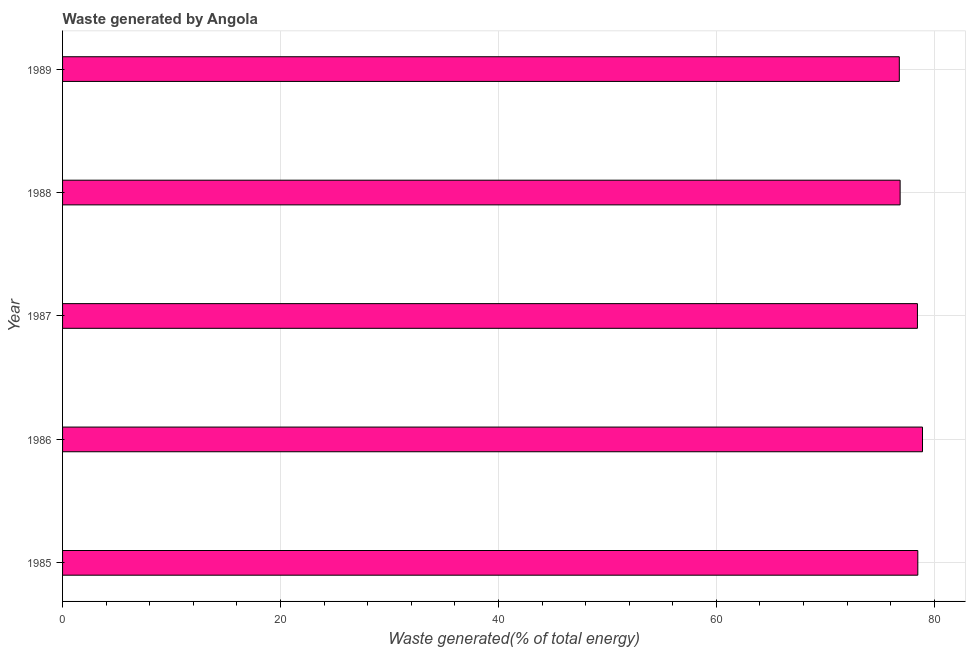Does the graph contain grids?
Offer a very short reply. Yes. What is the title of the graph?
Your response must be concise. Waste generated by Angola. What is the label or title of the X-axis?
Your response must be concise. Waste generated(% of total energy). What is the label or title of the Y-axis?
Your answer should be very brief. Year. What is the amount of waste generated in 1987?
Make the answer very short. 78.45. Across all years, what is the maximum amount of waste generated?
Your answer should be compact. 78.91. Across all years, what is the minimum amount of waste generated?
Give a very brief answer. 76.79. In which year was the amount of waste generated maximum?
Your response must be concise. 1986. In which year was the amount of waste generated minimum?
Keep it short and to the point. 1989. What is the sum of the amount of waste generated?
Provide a short and direct response. 389.5. What is the difference between the amount of waste generated in 1987 and 1988?
Make the answer very short. 1.59. What is the average amount of waste generated per year?
Make the answer very short. 77.9. What is the median amount of waste generated?
Ensure brevity in your answer.  78.45. Do a majority of the years between 1986 and 1985 (inclusive) have amount of waste generated greater than 32 %?
Keep it short and to the point. No. What is the ratio of the amount of waste generated in 1986 to that in 1989?
Give a very brief answer. 1.03. Is the amount of waste generated in 1985 less than that in 1988?
Your answer should be compact. No. Is the difference between the amount of waste generated in 1987 and 1989 greater than the difference between any two years?
Your response must be concise. No. What is the difference between the highest and the second highest amount of waste generated?
Your answer should be very brief. 0.43. Is the sum of the amount of waste generated in 1987 and 1989 greater than the maximum amount of waste generated across all years?
Offer a very short reply. Yes. What is the difference between the highest and the lowest amount of waste generated?
Ensure brevity in your answer.  2.13. What is the Waste generated(% of total energy) of 1985?
Provide a short and direct response. 78.48. What is the Waste generated(% of total energy) of 1986?
Give a very brief answer. 78.91. What is the Waste generated(% of total energy) of 1987?
Provide a succinct answer. 78.45. What is the Waste generated(% of total energy) of 1988?
Your answer should be compact. 76.86. What is the Waste generated(% of total energy) of 1989?
Your answer should be compact. 76.79. What is the difference between the Waste generated(% of total energy) in 1985 and 1986?
Your response must be concise. -0.43. What is the difference between the Waste generated(% of total energy) in 1985 and 1987?
Provide a succinct answer. 0.03. What is the difference between the Waste generated(% of total energy) in 1985 and 1988?
Your answer should be very brief. 1.62. What is the difference between the Waste generated(% of total energy) in 1985 and 1989?
Make the answer very short. 1.7. What is the difference between the Waste generated(% of total energy) in 1986 and 1987?
Provide a short and direct response. 0.46. What is the difference between the Waste generated(% of total energy) in 1986 and 1988?
Provide a short and direct response. 2.05. What is the difference between the Waste generated(% of total energy) in 1986 and 1989?
Give a very brief answer. 2.13. What is the difference between the Waste generated(% of total energy) in 1987 and 1988?
Provide a succinct answer. 1.59. What is the difference between the Waste generated(% of total energy) in 1987 and 1989?
Your response must be concise. 1.66. What is the difference between the Waste generated(% of total energy) in 1988 and 1989?
Your answer should be very brief. 0.07. What is the ratio of the Waste generated(% of total energy) in 1985 to that in 1986?
Give a very brief answer. 0.99. What is the ratio of the Waste generated(% of total energy) in 1985 to that in 1988?
Your response must be concise. 1.02. What is the ratio of the Waste generated(% of total energy) in 1986 to that in 1987?
Ensure brevity in your answer.  1.01. What is the ratio of the Waste generated(% of total energy) in 1986 to that in 1988?
Your response must be concise. 1.03. What is the ratio of the Waste generated(% of total energy) in 1986 to that in 1989?
Your answer should be compact. 1.03. What is the ratio of the Waste generated(% of total energy) in 1987 to that in 1988?
Your response must be concise. 1.02. 